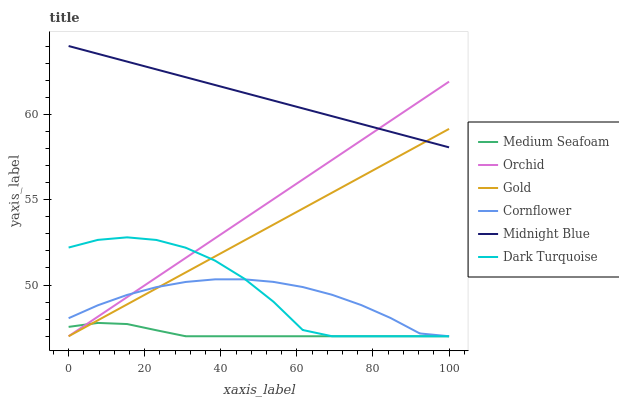Does Medium Seafoam have the minimum area under the curve?
Answer yes or no. Yes. Does Midnight Blue have the maximum area under the curve?
Answer yes or no. Yes. Does Gold have the minimum area under the curve?
Answer yes or no. No. Does Gold have the maximum area under the curve?
Answer yes or no. No. Is Midnight Blue the smoothest?
Answer yes or no. Yes. Is Dark Turquoise the roughest?
Answer yes or no. Yes. Is Gold the smoothest?
Answer yes or no. No. Is Gold the roughest?
Answer yes or no. No. Does Cornflower have the lowest value?
Answer yes or no. Yes. Does Midnight Blue have the lowest value?
Answer yes or no. No. Does Midnight Blue have the highest value?
Answer yes or no. Yes. Does Gold have the highest value?
Answer yes or no. No. Is Dark Turquoise less than Midnight Blue?
Answer yes or no. Yes. Is Midnight Blue greater than Dark Turquoise?
Answer yes or no. Yes. Does Midnight Blue intersect Gold?
Answer yes or no. Yes. Is Midnight Blue less than Gold?
Answer yes or no. No. Is Midnight Blue greater than Gold?
Answer yes or no. No. Does Dark Turquoise intersect Midnight Blue?
Answer yes or no. No. 